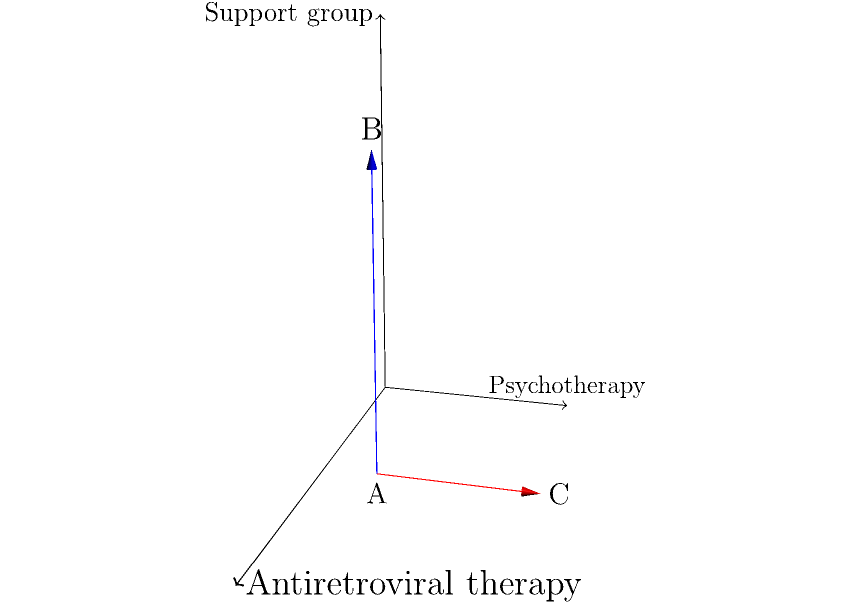In the context of HIV/AIDS treatment, vector A represents antiretroviral therapy (2i + j), vector B represents support group participation (2i + j + 3k), and vector C represents psychotherapy (2i + 4j). Calculate the magnitude of the cross product A × B, which represents the combined effectiveness of antiretroviral therapy and support group participation. How does this compare to the magnitude of A × C? To solve this problem, we'll follow these steps:

1) Calculate A × B:
   A = 2i + j
   B = 2i + j + 3k
   A × B = |(2)(3) - (1)(0)| i + |(1)(2) - (2)(3)| j + |(2)(1) - (2)(1)| k
         = 6i - 4j + 0k

2) Calculate the magnitude of A × B:
   |A × B| = $\sqrt{6^2 + (-4)^2 + 0^2} = \sqrt{36 + 16} = \sqrt{52} \approx 7.21$

3) Calculate A × C:
   A = 2i + j
   C = 2i + 4j
   A × C = |(2)(0) - (1)(0)| i + |(1)(2) - (2)(4)| j + |(2)(4) - (2)(2)| k
         = 0i - 6j + 4k

4) Calculate the magnitude of A × C:
   |A × C| = $\sqrt{0^2 + (-6)^2 + 4^2} = \sqrt{36 + 16} = \sqrt{52} \approx 7.21$

5) Compare the magnitudes:
   The magnitudes of A × B and A × C are equal, both approximately 7.21.

This result suggests that the combined effectiveness of antiretroviral therapy with support group participation is equal to the combined effectiveness of antiretroviral therapy with psychotherapy, in terms of their cross product magnitudes.
Answer: |A × B| = |A × C| ≈ 7.21 